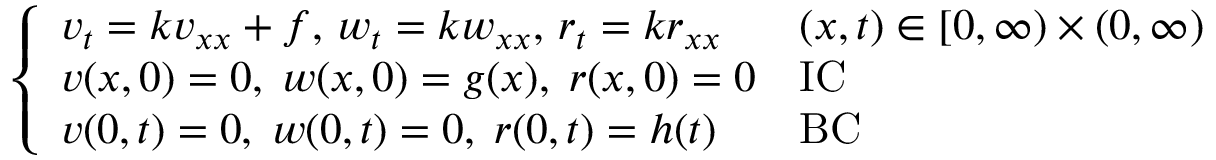Convert formula to latex. <formula><loc_0><loc_0><loc_500><loc_500>{ \left \{ \begin{array} { l l } { v _ { t } = k v _ { x x } + f , \, w _ { t } = k w _ { x x } , \, r _ { t } = k r _ { x x } } & { ( x , t ) \in [ 0 , \infty ) \times ( 0 , \infty ) } \\ { v ( x , 0 ) = 0 , \, w ( x , 0 ) = g ( x ) , \, r ( x , 0 ) = 0 } & { I C } \\ { v ( 0 , t ) = 0 , \, w ( 0 , t ) = 0 , \, r ( 0 , t ) = h ( t ) } & { B C } \end{array} }</formula> 